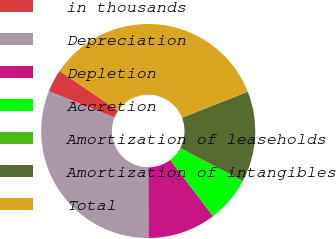Convert chart to OTSL. <chart><loc_0><loc_0><loc_500><loc_500><pie_chart><fcel>in thousands<fcel>Depreciation<fcel>Depletion<fcel>Accretion<fcel>Amortization of leaseholds<fcel>Amortization of intangibles<fcel>Total<nl><fcel>3.45%<fcel>31.1%<fcel>10.3%<fcel>6.87%<fcel>0.02%<fcel>13.73%<fcel>34.53%<nl></chart> 